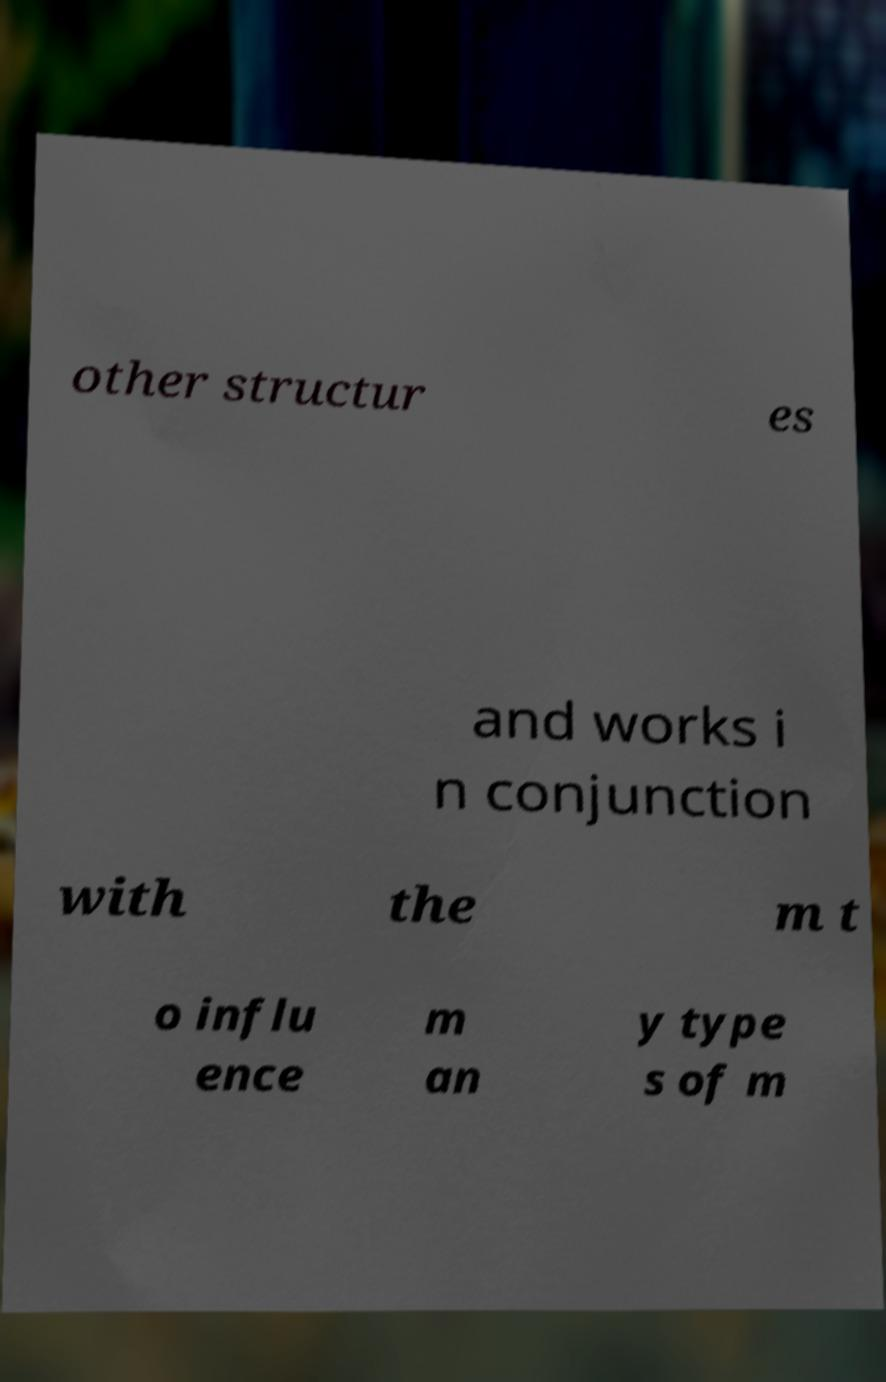Could you extract and type out the text from this image? other structur es and works i n conjunction with the m t o influ ence m an y type s of m 